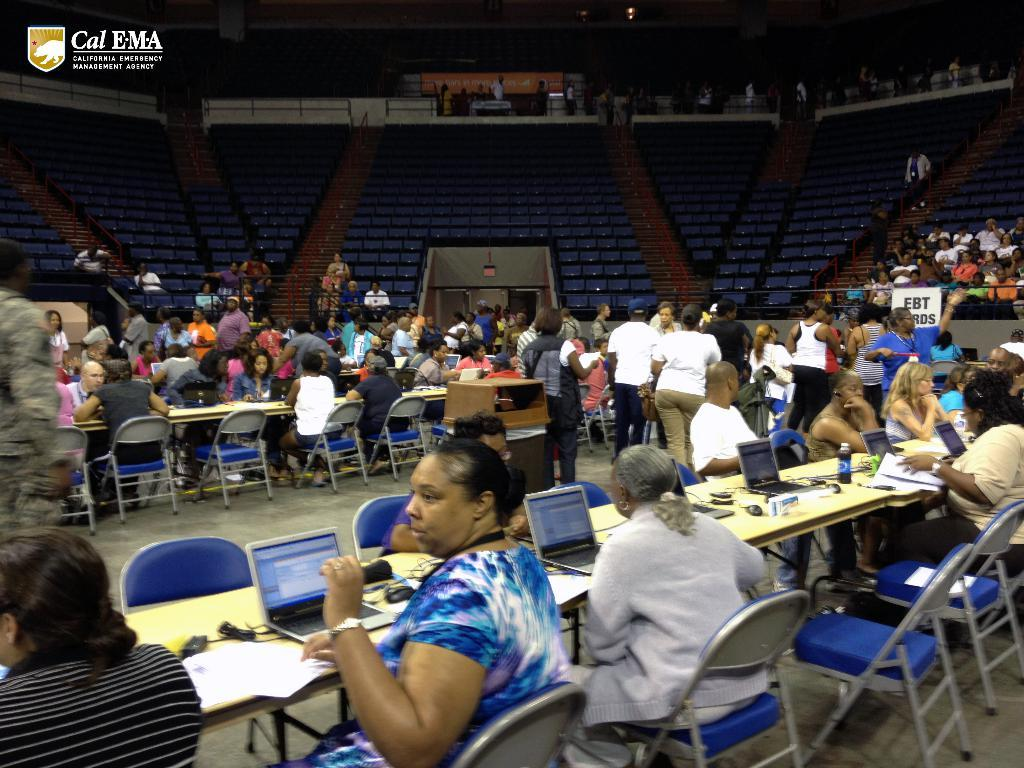What are the majority of people in the image doing? Most of the persons are sitting on chairs. What can be seen on the table in the image? There are laptops, a bottle, and papers on the table. What type of plant is growing on the table in the image? There is no plant visible on the table in the image. 